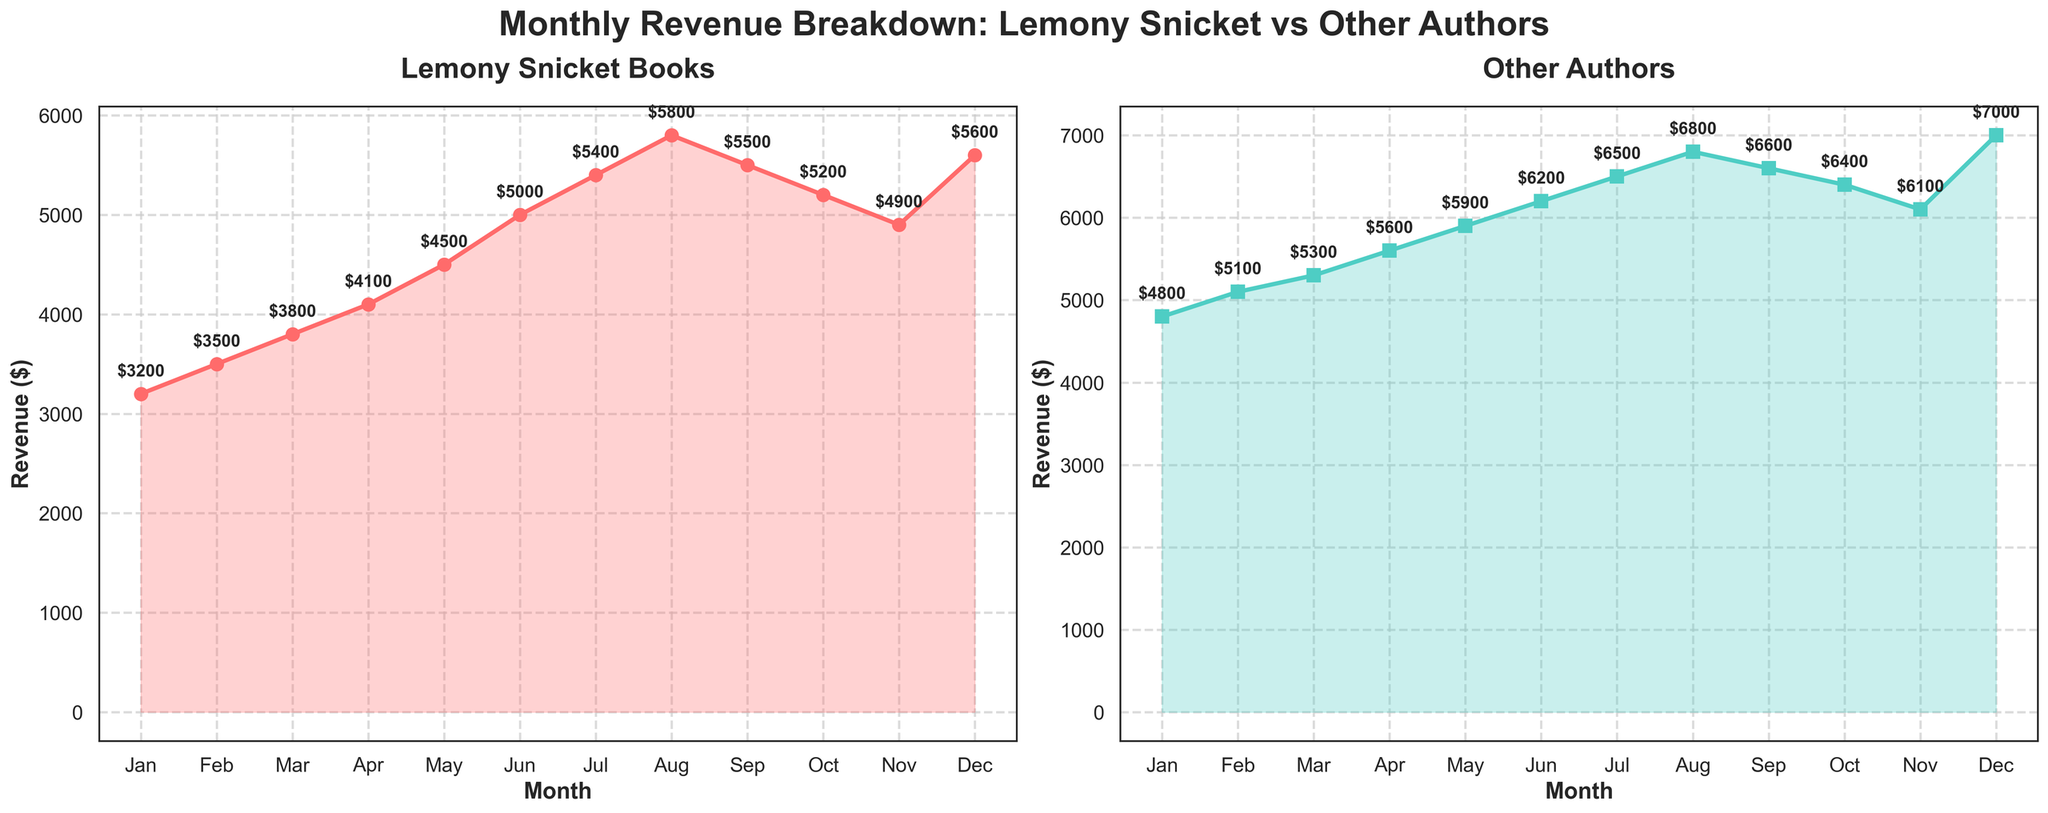Which month had the highest revenue for Lemony Snicket books? By examining the plot for Lemony Snicket Books, we see that August had the highest revenue value marked, which is $5800.
Answer: August What is the total revenue for Lemony Snicket books over the year? Summing the monthly revenues from the Lemony Snicket plot: 3200 + 3500 + 3800 + 4100 + 4500 + 5000 + 5400 + 5800 + 5500 + 5200 + 4900 + 5600 = 60500.
Answer: $60500 Which month had the smallest difference in revenue between Lemony Snicket and Other Authors? Calculate the revenue differences for each month: Jan (1600), Feb (1600), Mar (1500), Apr (1500), May (1400), Jun (1200), Jul (1100), Aug (1000), Sep (1100), Oct (1200), Nov (1200), Dec (1400). The smallest difference is in August, with a difference of $1000.
Answer: August In which months did the revenue for Lemony Snicket books and Other Authors show an increasing trend? From the plots, both Lemony Snicket books and Other Authors show increasing trends from January to August.
Answer: January to August What is the average monthly revenue for Other Authors? Sum the monthly revenues for Other Authors: 4800 + 5100 + 5300 + 5600 + 5900 + 6200 + 6500 + 6800 + 6600 + 6400 + 6100 + 7000 = 72300. Divide by 12 to get the average: 72300 / 12 = 6025.
Answer: $6025 Which category saw a larger increase in revenue from January to December? The January revenue for Lemony Snicket is $3200, and December is $5600. The increase is 5600 - 3200 = $2400. For Other Authors, January is $4800, and December is $7000. The increase is 7000 - 4800 = $2200. Lemony Snicket saw a larger increase.
Answer: Lemony Snicket What is the median revenue month for Lemony Snicket books based on the ascending order of revenues? Ordering the monthly revenues for Lemony Snicket: 3200, 3500, 3800, 4100, 4500, 4900, 5000, 5200, 5400, 5500, 5600, 5800. The middle values are 4900 and 5000. The median is (4900 + 5000) / 2 = 4950.
Answer: $4950 How does the peak revenue month for Other Authors compare to Lemony Snicket? The peak revenue month for Other Authors is December with $7000, whereas for Lemony Snicket, it's August with $5800. Other Authors' peak revenue is higher by 7000 - 5800 = $1200.
Answer: Higher by $1200 During which months did Lemony Snicket books earn less than $5000? From the Lemony Snicket plot, the months with revenues less than $5000 are January, February, March, April, and November.
Answer: January, February, March, April, November What can you infer about the revenue trends for the two categories throughout the year? The revenue for both Lemony Snicket books and Other Authors generally increased from January to August. From September, both showed a decline, but Other Authors peaked again in December.
Answer: Increasing till August, then declining with a December peak for Other Authors 